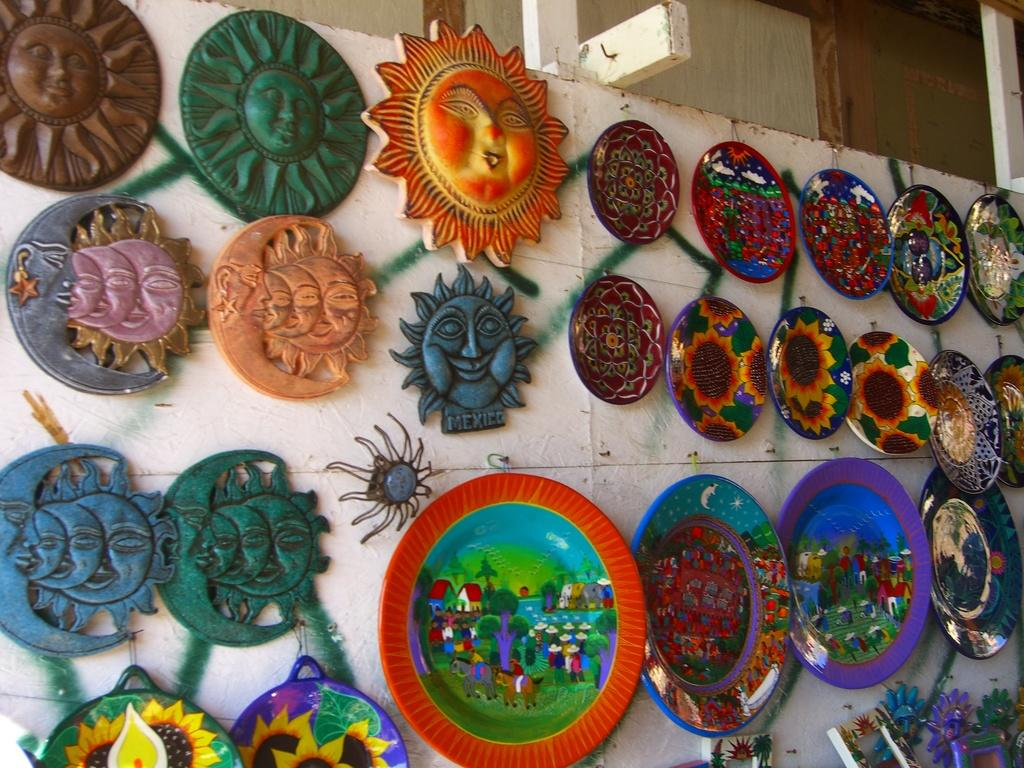What type of objects can be seen on the plates in the image? The provided facts do not specify what is on the plates, so we cannot answer that question definitively. What other objects are present on the wall in the image? The provided facts only mention that there are other objects on the wall, but do not specify what they are. What type of berry is growing on the twig in the image? There is no berry or twig present in the image. How does the society depicted in the image contribute to the overall theme? There is no society depicted in the image, so we cannot answer that question. 